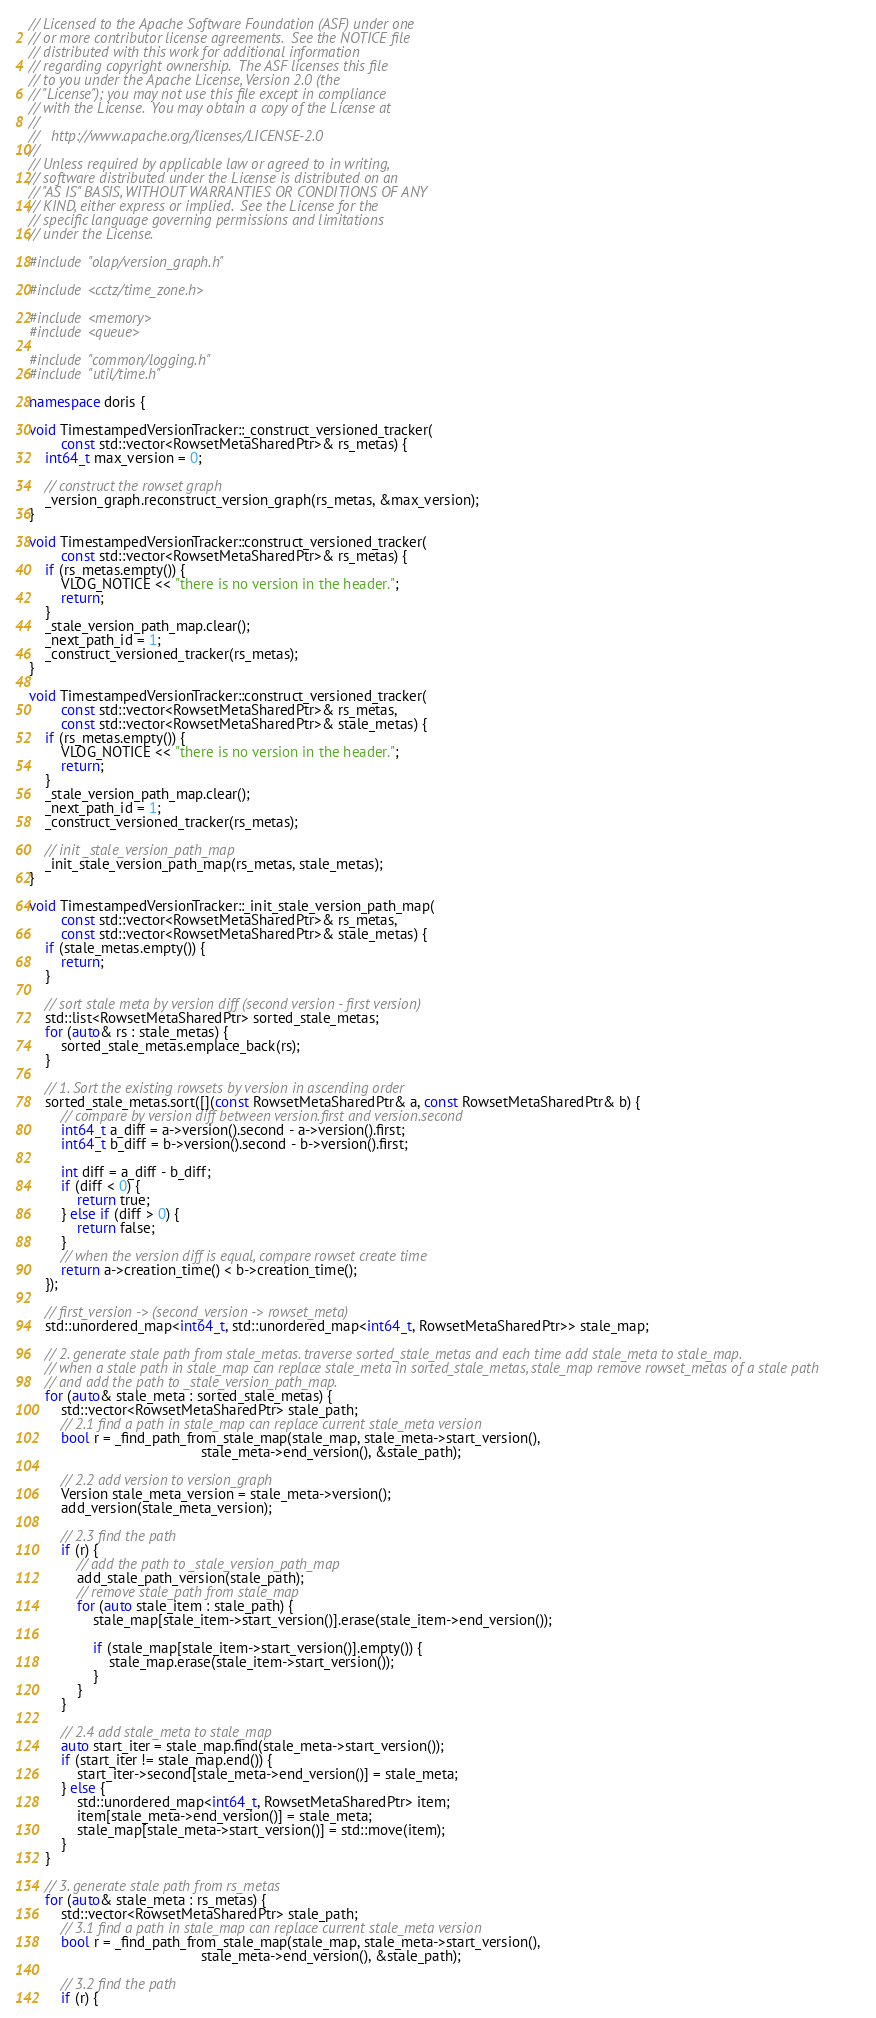<code> <loc_0><loc_0><loc_500><loc_500><_C++_>// Licensed to the Apache Software Foundation (ASF) under one
// or more contributor license agreements.  See the NOTICE file
// distributed with this work for additional information
// regarding copyright ownership.  The ASF licenses this file
// to you under the Apache License, Version 2.0 (the
// "License"); you may not use this file except in compliance
// with the License.  You may obtain a copy of the License at
//
//   http://www.apache.org/licenses/LICENSE-2.0
//
// Unless required by applicable law or agreed to in writing,
// software distributed under the License is distributed on an
// "AS IS" BASIS, WITHOUT WARRANTIES OR CONDITIONS OF ANY
// KIND, either express or implied.  See the License for the
// specific language governing permissions and limitations
// under the License.

#include "olap/version_graph.h"

#include <cctz/time_zone.h>

#include <memory>
#include <queue>

#include "common/logging.h"
#include "util/time.h"

namespace doris {

void TimestampedVersionTracker::_construct_versioned_tracker(
        const std::vector<RowsetMetaSharedPtr>& rs_metas) {
    int64_t max_version = 0;

    // construct the rowset graph
    _version_graph.reconstruct_version_graph(rs_metas, &max_version);
}

void TimestampedVersionTracker::construct_versioned_tracker(
        const std::vector<RowsetMetaSharedPtr>& rs_metas) {
    if (rs_metas.empty()) {
        VLOG_NOTICE << "there is no version in the header.";
        return;
    }
    _stale_version_path_map.clear();
    _next_path_id = 1;
    _construct_versioned_tracker(rs_metas);
}

void TimestampedVersionTracker::construct_versioned_tracker(
        const std::vector<RowsetMetaSharedPtr>& rs_metas,
        const std::vector<RowsetMetaSharedPtr>& stale_metas) {
    if (rs_metas.empty()) {
        VLOG_NOTICE << "there is no version in the header.";
        return;
    }
    _stale_version_path_map.clear();
    _next_path_id = 1;
    _construct_versioned_tracker(rs_metas);

    // init _stale_version_path_map
    _init_stale_version_path_map(rs_metas, stale_metas);
}

void TimestampedVersionTracker::_init_stale_version_path_map(
        const std::vector<RowsetMetaSharedPtr>& rs_metas,
        const std::vector<RowsetMetaSharedPtr>& stale_metas) {
    if (stale_metas.empty()) {
        return;
    }

    // sort stale meta by version diff (second version - first version)
    std::list<RowsetMetaSharedPtr> sorted_stale_metas;
    for (auto& rs : stale_metas) {
        sorted_stale_metas.emplace_back(rs);
    }

    // 1. Sort the existing rowsets by version in ascending order
    sorted_stale_metas.sort([](const RowsetMetaSharedPtr& a, const RowsetMetaSharedPtr& b) {
        // compare by version diff between version.first and version.second
        int64_t a_diff = a->version().second - a->version().first;
        int64_t b_diff = b->version().second - b->version().first;

        int diff = a_diff - b_diff;
        if (diff < 0) {
            return true;
        } else if (diff > 0) {
            return false;
        }
        // when the version diff is equal, compare rowset create time
        return a->creation_time() < b->creation_time();
    });

    // first_version -> (second_version -> rowset_meta)
    std::unordered_map<int64_t, std::unordered_map<int64_t, RowsetMetaSharedPtr>> stale_map;

    // 2. generate stale path from stale_metas. traverse sorted_stale_metas and each time add stale_meta to stale_map.
    // when a stale path in stale_map can replace stale_meta in sorted_stale_metas, stale_map remove rowset_metas of a stale path
    // and add the path to _stale_version_path_map.
    for (auto& stale_meta : sorted_stale_metas) {
        std::vector<RowsetMetaSharedPtr> stale_path;
        // 2.1 find a path in stale_map can replace current stale_meta version
        bool r = _find_path_from_stale_map(stale_map, stale_meta->start_version(),
                                           stale_meta->end_version(), &stale_path);

        // 2.2 add version to version_graph
        Version stale_meta_version = stale_meta->version();
        add_version(stale_meta_version);

        // 2.3 find the path
        if (r) {
            // add the path to _stale_version_path_map
            add_stale_path_version(stale_path);
            // remove stale_path from stale_map
            for (auto stale_item : stale_path) {
                stale_map[stale_item->start_version()].erase(stale_item->end_version());

                if (stale_map[stale_item->start_version()].empty()) {
                    stale_map.erase(stale_item->start_version());
                }
            }
        }

        // 2.4 add stale_meta to stale_map
        auto start_iter = stale_map.find(stale_meta->start_version());
        if (start_iter != stale_map.end()) {
            start_iter->second[stale_meta->end_version()] = stale_meta;
        } else {
            std::unordered_map<int64_t, RowsetMetaSharedPtr> item;
            item[stale_meta->end_version()] = stale_meta;
            stale_map[stale_meta->start_version()] = std::move(item);
        }
    }

    // 3. generate stale path from rs_metas
    for (auto& stale_meta : rs_metas) {
        std::vector<RowsetMetaSharedPtr> stale_path;
        // 3.1 find a path in stale_map can replace current stale_meta version
        bool r = _find_path_from_stale_map(stale_map, stale_meta->start_version(),
                                           stale_meta->end_version(), &stale_path);

        // 3.2 find the path
        if (r) {</code> 